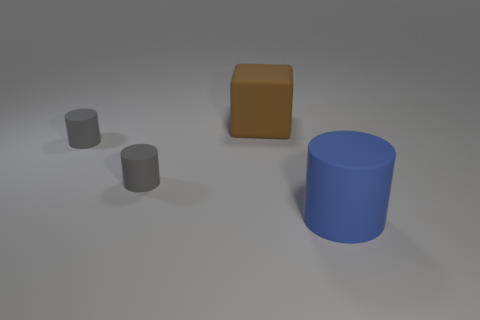Are there any brown blocks left of the large thing to the right of the large matte thing behind the big rubber cylinder?
Give a very brief answer. Yes. Are there any other things of the same color as the large block?
Offer a very short reply. No. The big object behind the cylinder right of the brown rubber block is what color?
Your answer should be compact. Brown. There is a big brown matte object; are there any brown rubber blocks on the left side of it?
Make the answer very short. No. How many small gray cylinders are there?
Ensure brevity in your answer.  2. How many large things are in front of the big object that is behind the large rubber cylinder?
Keep it short and to the point. 1. There is a big block; is its color the same as the rubber cylinder to the right of the brown block?
Ensure brevity in your answer.  No. How many gray matte things are the same shape as the big blue object?
Your answer should be very brief. 2. What is the material of the big object on the left side of the large cylinder?
Provide a short and direct response. Rubber. Are there any rubber cylinders that have the same size as the matte cube?
Provide a succinct answer. Yes. 